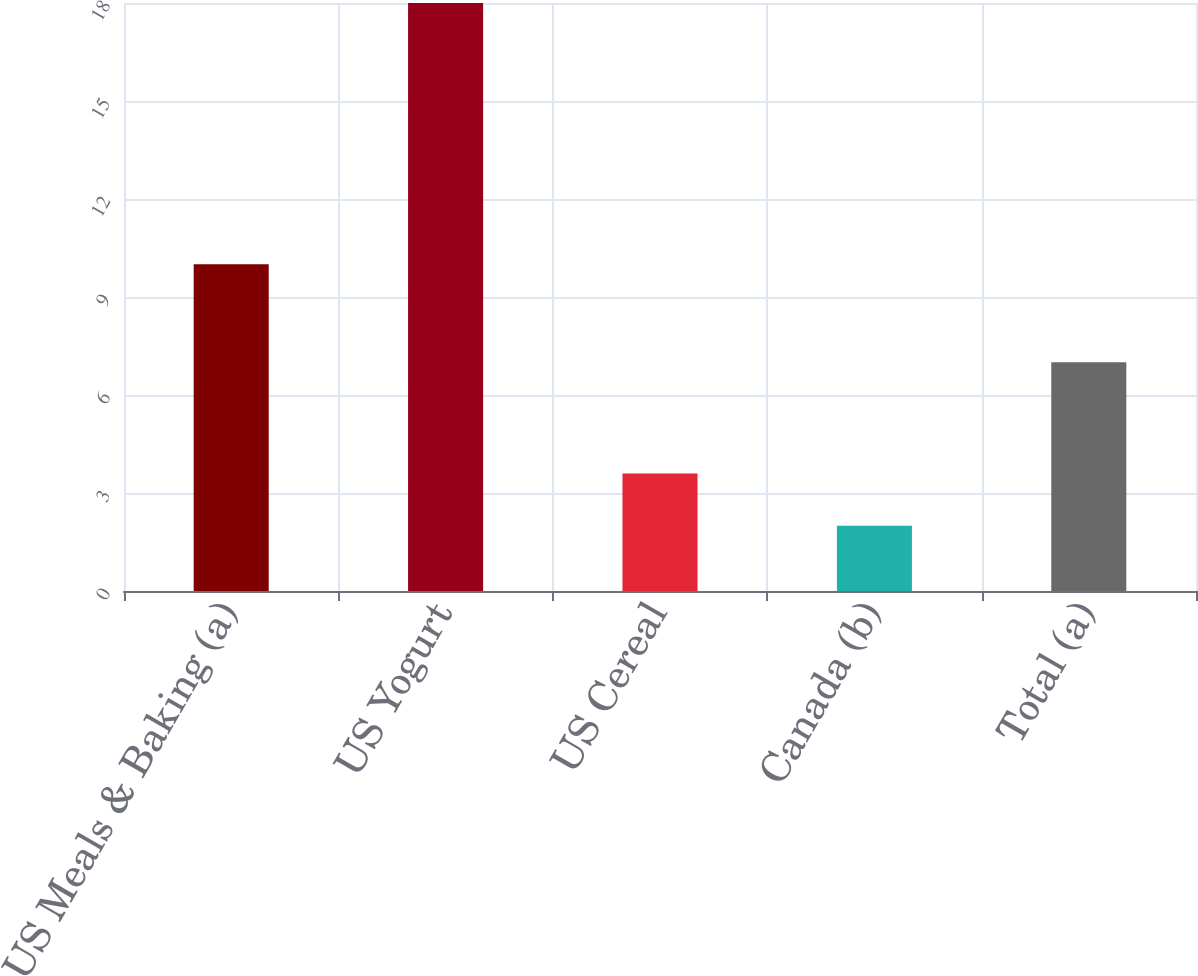<chart> <loc_0><loc_0><loc_500><loc_500><bar_chart><fcel>US Meals & Baking (a)<fcel>US Yogurt<fcel>US Cereal<fcel>Canada (b)<fcel>Total (a)<nl><fcel>10<fcel>18<fcel>3.6<fcel>2<fcel>7<nl></chart> 